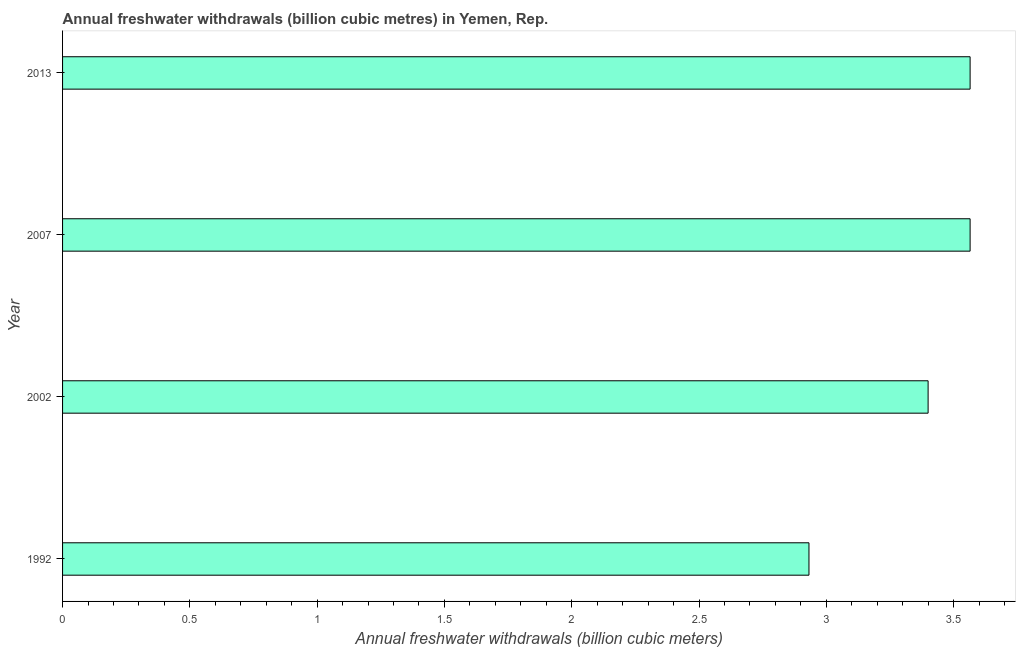Does the graph contain any zero values?
Ensure brevity in your answer.  No. Does the graph contain grids?
Give a very brief answer. No. What is the title of the graph?
Your response must be concise. Annual freshwater withdrawals (billion cubic metres) in Yemen, Rep. What is the label or title of the X-axis?
Make the answer very short. Annual freshwater withdrawals (billion cubic meters). What is the label or title of the Y-axis?
Your response must be concise. Year. What is the annual freshwater withdrawals in 2002?
Your response must be concise. 3.4. Across all years, what is the maximum annual freshwater withdrawals?
Give a very brief answer. 3.56. Across all years, what is the minimum annual freshwater withdrawals?
Your answer should be compact. 2.93. In which year was the annual freshwater withdrawals maximum?
Give a very brief answer. 2007. What is the sum of the annual freshwater withdrawals?
Make the answer very short. 13.46. What is the difference between the annual freshwater withdrawals in 1992 and 2002?
Make the answer very short. -0.47. What is the average annual freshwater withdrawals per year?
Keep it short and to the point. 3.37. What is the median annual freshwater withdrawals?
Offer a very short reply. 3.48. Do a majority of the years between 2002 and 2013 (inclusive) have annual freshwater withdrawals greater than 0.4 billion cubic meters?
Offer a very short reply. Yes. What is the ratio of the annual freshwater withdrawals in 1992 to that in 2007?
Offer a very short reply. 0.82. Is the annual freshwater withdrawals in 2007 less than that in 2013?
Keep it short and to the point. No. Is the difference between the annual freshwater withdrawals in 2002 and 2013 greater than the difference between any two years?
Give a very brief answer. No. Is the sum of the annual freshwater withdrawals in 1992 and 2007 greater than the maximum annual freshwater withdrawals across all years?
Your response must be concise. Yes. What is the difference between the highest and the lowest annual freshwater withdrawals?
Give a very brief answer. 0.63. In how many years, is the annual freshwater withdrawals greater than the average annual freshwater withdrawals taken over all years?
Give a very brief answer. 3. How many bars are there?
Offer a terse response. 4. Are all the bars in the graph horizontal?
Ensure brevity in your answer.  Yes. What is the Annual freshwater withdrawals (billion cubic meters) of 1992?
Provide a short and direct response. 2.93. What is the Annual freshwater withdrawals (billion cubic meters) in 2002?
Give a very brief answer. 3.4. What is the Annual freshwater withdrawals (billion cubic meters) of 2007?
Your answer should be compact. 3.56. What is the Annual freshwater withdrawals (billion cubic meters) of 2013?
Keep it short and to the point. 3.56. What is the difference between the Annual freshwater withdrawals (billion cubic meters) in 1992 and 2002?
Ensure brevity in your answer.  -0.47. What is the difference between the Annual freshwater withdrawals (billion cubic meters) in 1992 and 2007?
Offer a terse response. -0.63. What is the difference between the Annual freshwater withdrawals (billion cubic meters) in 1992 and 2013?
Make the answer very short. -0.63. What is the difference between the Annual freshwater withdrawals (billion cubic meters) in 2002 and 2007?
Your answer should be very brief. -0.17. What is the difference between the Annual freshwater withdrawals (billion cubic meters) in 2002 and 2013?
Give a very brief answer. -0.17. What is the ratio of the Annual freshwater withdrawals (billion cubic meters) in 1992 to that in 2002?
Your answer should be compact. 0.86. What is the ratio of the Annual freshwater withdrawals (billion cubic meters) in 1992 to that in 2007?
Offer a terse response. 0.82. What is the ratio of the Annual freshwater withdrawals (billion cubic meters) in 1992 to that in 2013?
Make the answer very short. 0.82. What is the ratio of the Annual freshwater withdrawals (billion cubic meters) in 2002 to that in 2007?
Your response must be concise. 0.95. What is the ratio of the Annual freshwater withdrawals (billion cubic meters) in 2002 to that in 2013?
Ensure brevity in your answer.  0.95. What is the ratio of the Annual freshwater withdrawals (billion cubic meters) in 2007 to that in 2013?
Keep it short and to the point. 1. 